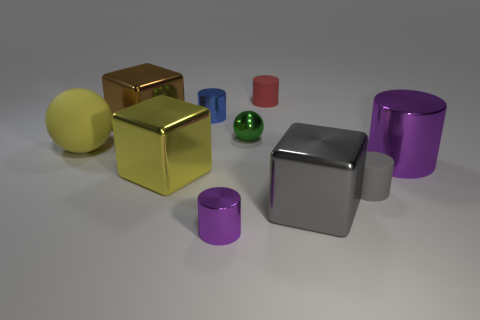Can you tell me which object stands out the most and why? The golden cube stands out due to its eye-catching glossy finish and vibrant color, which contrasts sharply with the other more muted or reflective surfaces. The use of a golden hue often captures attention for its association with wealth, value, and rarity. If you had to use one of these objects to teach a concept, which one would you choose and what concept would you teach? I would choose the sphere to teach the concept of geometry and symmetry. Unlike the other shapes, the sphere has no edges or vertices and is perfectly symmetrical from all perspectives, making it an ideal example to explain concepts such as radius, diameter, and the calculation of volume and surface area for curved surfaces. 